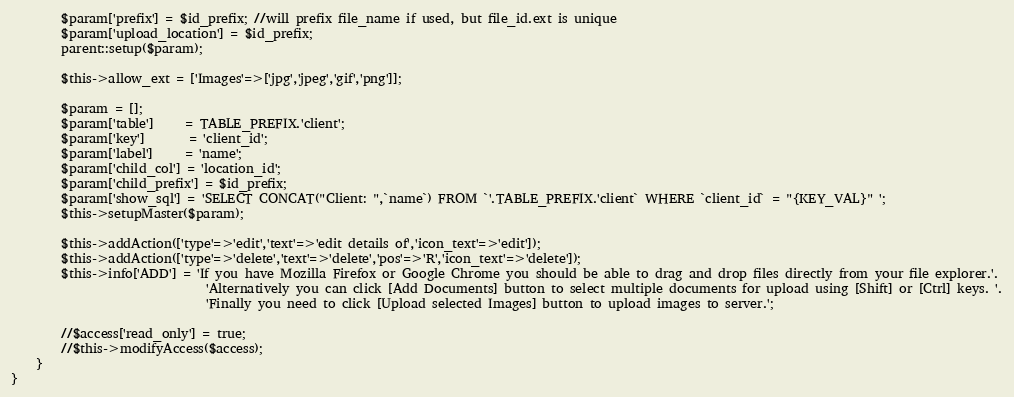<code> <loc_0><loc_0><loc_500><loc_500><_PHP_>        $param['prefix'] = $id_prefix; //will prefix file_name if used, but file_id.ext is unique
        $param['upload_location'] = $id_prefix;
        parent::setup($param);

        $this->allow_ext = ['Images'=>['jpg','jpeg','gif','png']]; 

        $param = [];
        $param['table']     = TABLE_PREFIX.'client';
        $param['key']       = 'client_id';
        $param['label']     = 'name';
        $param['child_col'] = 'location_id';
        $param['child_prefix'] = $id_prefix;
        $param['show_sql'] = 'SELECT CONCAT("Client: ",`name`) FROM `'.TABLE_PREFIX.'client` WHERE `client_id` = "{KEY_VAL}" ';
        $this->setupMaster($param);

        $this->addAction(['type'=>'edit','text'=>'edit details of','icon_text'=>'edit']);
        $this->addAction(['type'=>'delete','text'=>'delete','pos'=>'R','icon_text'=>'delete']);
        $this->info['ADD'] = 'If you have Mozilla Firefox or Google Chrome you should be able to drag and drop files directly from your file explorer.'.
                               'Alternatively you can click [Add Documents] button to select multiple documents for upload using [Shift] or [Ctrl] keys. '.
                               'Finally you need to click [Upload selected Images] button to upload images to server.';

        //$access['read_only'] = true;
        //$this->modifyAccess($access);
    }
}
</code> 